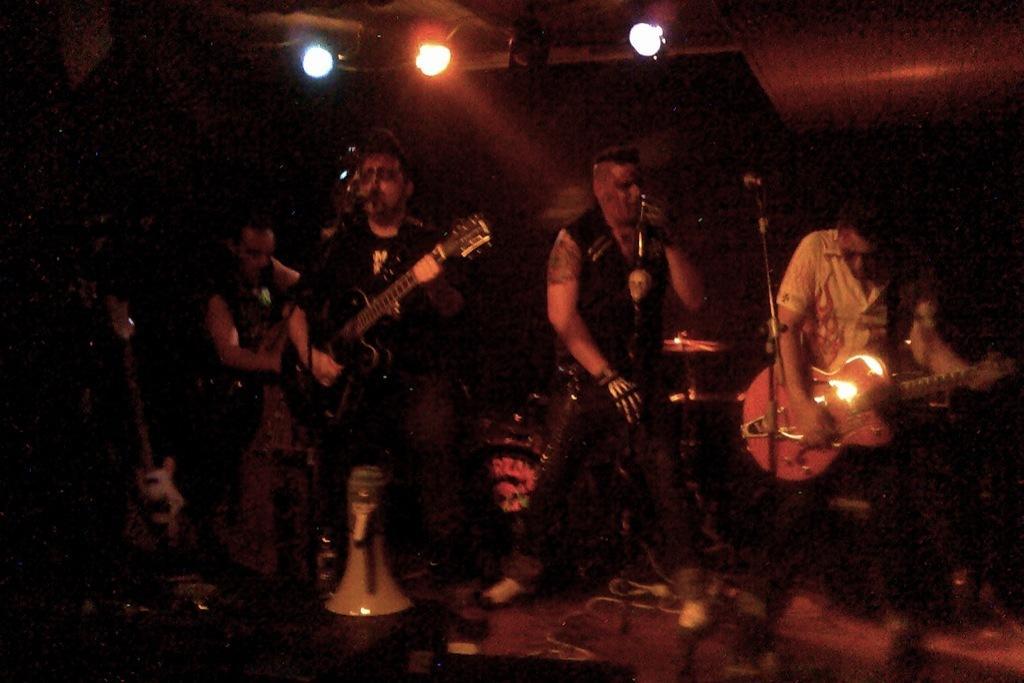Can you describe this image briefly? A rock band is performing on a stage. In the band two are playing guitar and one is singing in between them. There is another man playing drums. 